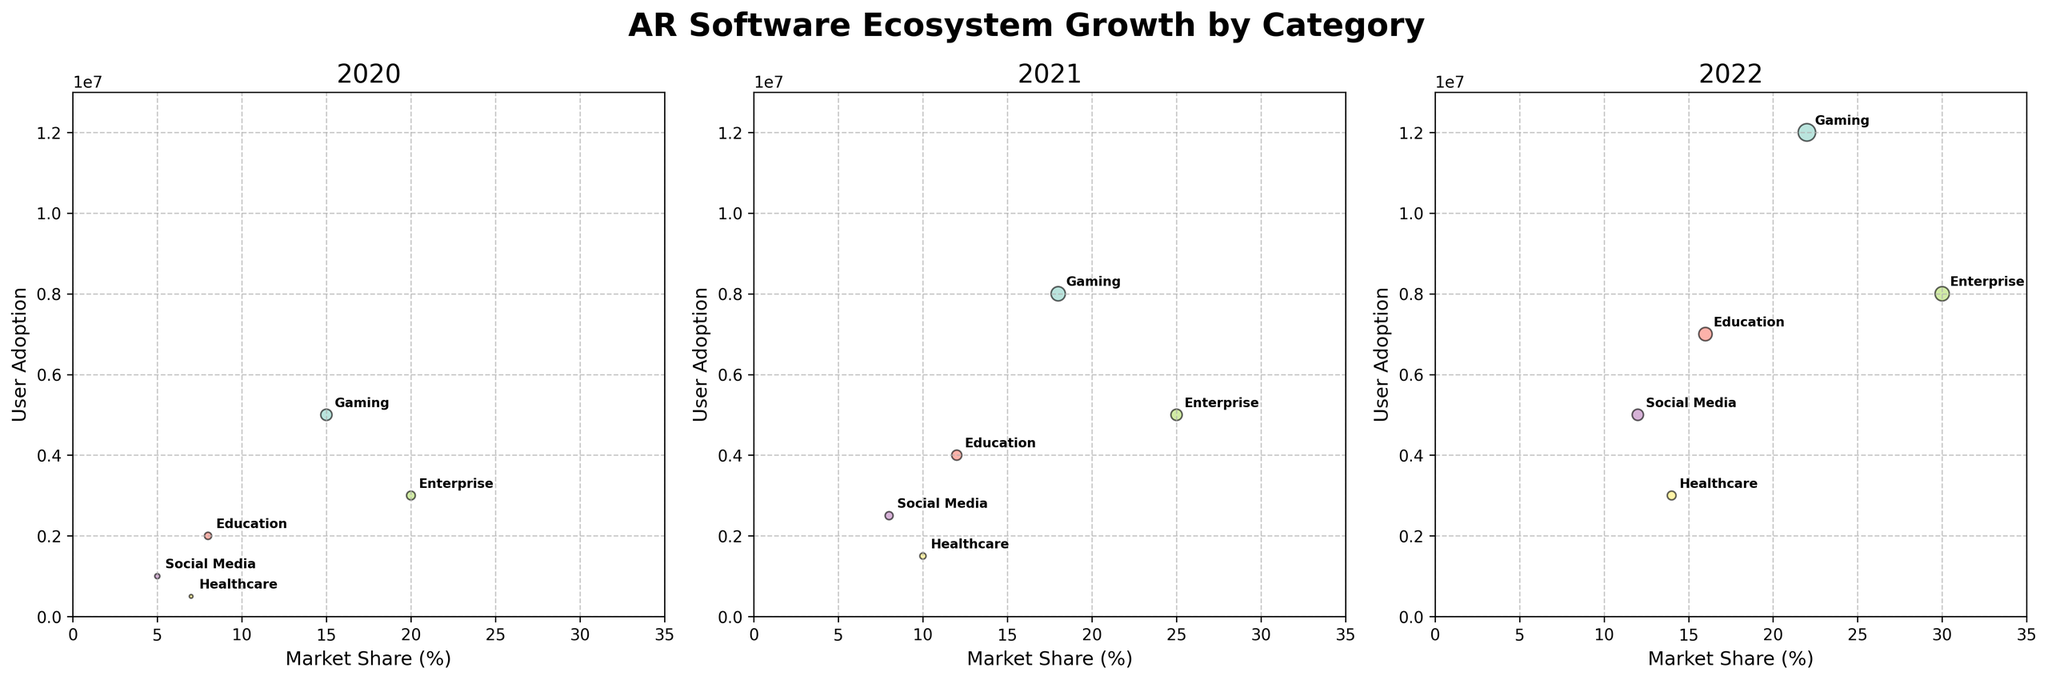What is the title of the figure? The title of the figure is typically located at the top center of the plot and provides a concise description of the content. In this case, it reads "AR Software Ecosystem Growth by Category".
Answer: AR Software Ecosystem Growth by Category How many categories are shown in the figure? By observing the figure, one can count the distinct labeled annotations within each subplot. The categories annotated are Gaming, Education, Enterprise, Social Media, and Healthcare.
Answer: 5 Which category had the highest user adoption in 2022? Examine the subplot for 2022 and identify the bubble with the highest y-axis value, as the y-axis represents user adoption. The largest bubble sits at 12,000,000 user adoptions, representing the Gaming category.
Answer: Gaming What is the market share percentage for the Healthcare category in 2021? Look at the subplot for the year 2021, find the label "Healthcare", and then trace it to the x-axis, which represents market share. The value next to Healthcare is 10%.
Answer: 10% Which category shows the most significant increase in user adoption from 2020 to 2022? Calculate the difference in user adoption between 2022 and 2020 for all categories. Gaming increases from 5,000,000 to 12,000,000, Education from 2,000,000 to 7,000,000, Enterprise from 3,000,000 to 8,000,000, Social Media from 1,000,000 to 5,000,000, and Healthcare from 500,000 to 3,000,000. The greatest increase is in Gaming (7,000,000).
Answer: Gaming Compare the market share of the Enterprise category in 2020 and 2022. Which year had a higher market share? Locate the "Enterprise" label on the 2020 and 2022 subplots. In 2020, the market share is 20%. In 2022, it is 30%. Thus, 2022 has the higher market share.
Answer: 2022 What trend can be observed for Social Media category user adoption from 2020 to 2022? Inspect the y-axis positions of the "Social Media" bubbles across the subplots for 2020, 2021, and 2022. In 2020, it's 1,000,000, in 2021, it's 2,500,000, and in 2022, it's 5,000,000 — showing a consistent increase.
Answer: Increasing Which categories have a market share greater than 10% in all three years? Observe each subplot and identify categories consistently placed above 10% on the x-axis for all three years. Only Enterprise (20%, 25%, 30%) and Gaming (15%, 18%, 22%) meet this criterion.
Answer: Enterprise, Gaming How did the Healthcare category's user adoption change from 2021 to 2022? Focus on the "Healthcare" label in the 2021 and 2022 subplots, then trace their y-axis values. In 2021, the value is 1,500,000; in 2022, it is 3,000,000. Subtract 1,500,000 from 3,000,000 to find the change in adoption.
Answer: Increased by 1,500,000 